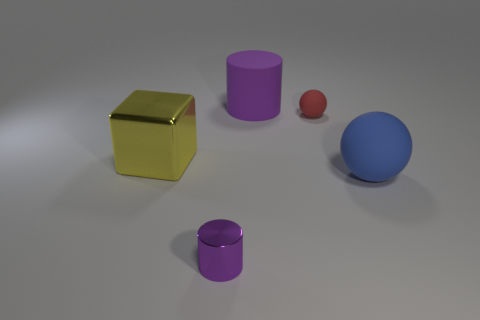Is the red matte object the same shape as the large blue matte object?
Make the answer very short. Yes. What size is the yellow cube?
Give a very brief answer. Large. The object that is in front of the big yellow shiny thing and on the right side of the purple matte object is what color?
Your response must be concise. Blue. Is the number of yellow metal cubes greater than the number of green matte blocks?
Offer a very short reply. Yes. What number of things are either purple rubber things or purple cylinders in front of the yellow metallic cube?
Offer a terse response. 2. Do the purple metal cylinder and the block have the same size?
Offer a very short reply. No. There is a big cylinder; are there any red matte spheres to the right of it?
Offer a very short reply. Yes. There is a object that is in front of the cube and left of the purple matte cylinder; how big is it?
Provide a succinct answer. Small. How many objects are either large cyan cylinders or spheres?
Offer a terse response. 2. Do the red object and the purple cylinder that is behind the big shiny cube have the same size?
Ensure brevity in your answer.  No. 